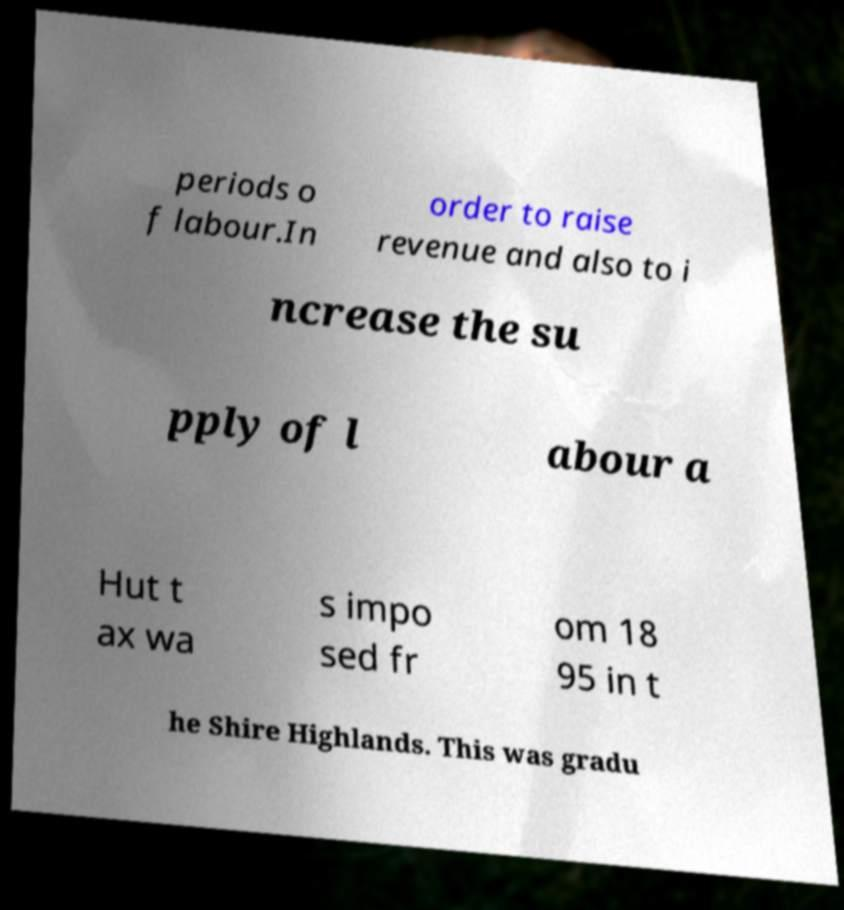Please identify and transcribe the text found in this image. periods o f labour.In order to raise revenue and also to i ncrease the su pply of l abour a Hut t ax wa s impo sed fr om 18 95 in t he Shire Highlands. This was gradu 